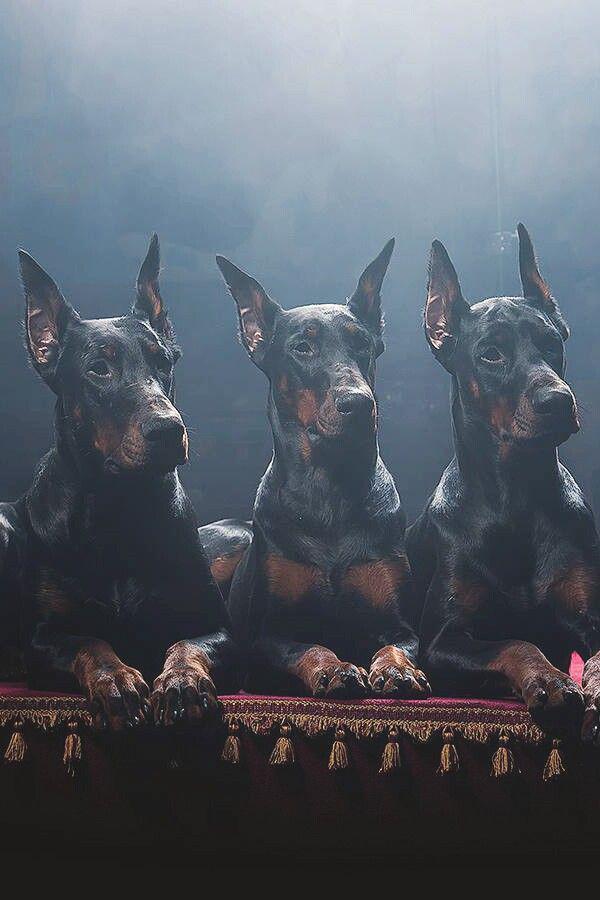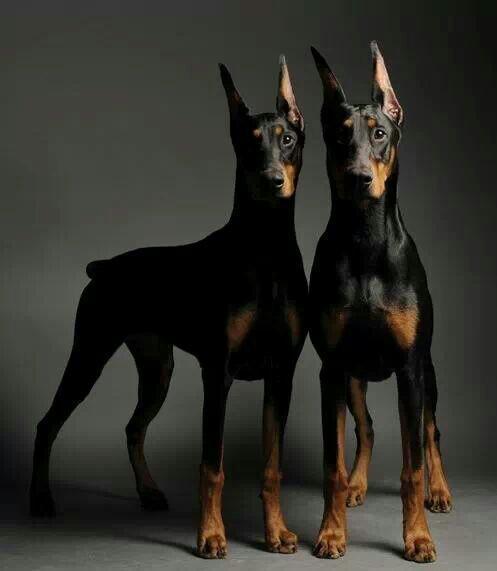The first image is the image on the left, the second image is the image on the right. Assess this claim about the two images: "Each image contains the same number of dogs, at least one of the dogs depicted gazes straight forward, and all dogs are erect-eared doberman.". Correct or not? Answer yes or no. No. The first image is the image on the left, the second image is the image on the right. Evaluate the accuracy of this statement regarding the images: "The left image contains at least two dogs.". Is it true? Answer yes or no. Yes. 